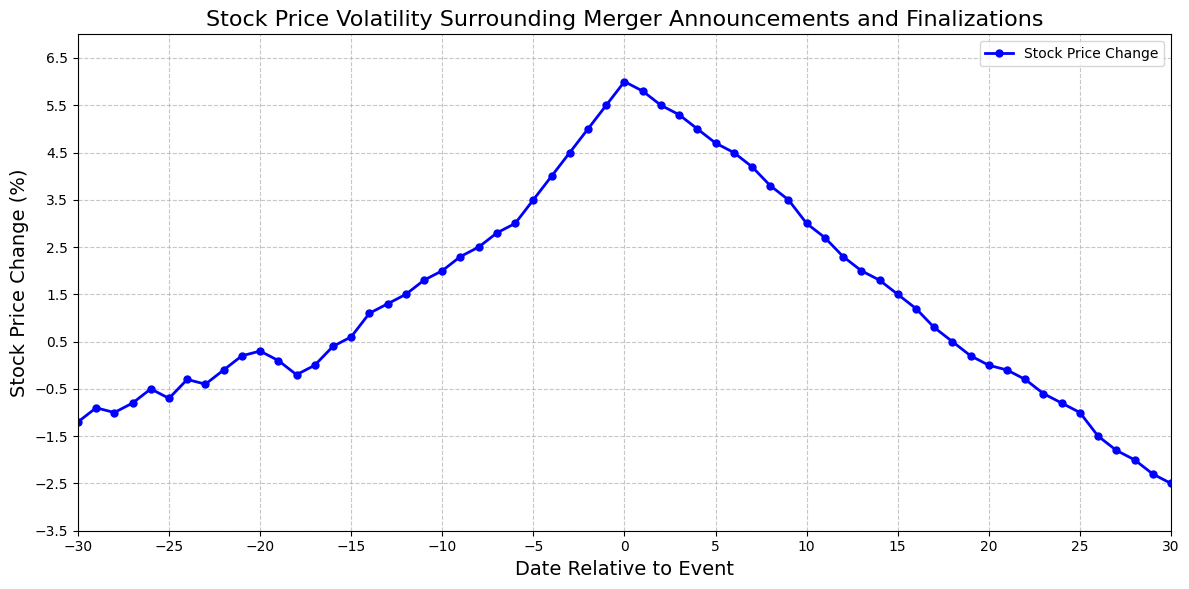What is the stock price change on the day of the merger announcement? To find the stock price change on the day of the merger announcement, look for the data point where the Date is 0. According to the data, on Date 0, the Stock Price Change is 6.0%.
Answer: 6.0% What is the highest stock price change before the merger announcement? To find the highest stock price change before the merger announcement, look at the data points where the Date is less than 0. The highest value among these is 5.5% on Date -1.
Answer: 5.5% What is the trend of the stock price change after the merger finalization? Analyze the data after Date 0. The stock price gradually declines from 6.0% on Date 0 to -2.5% on Date 30.
Answer: Gradually declines What is the total change in stock price from 10 days before to 10 days after the merger? To find the total change, sum the stock price changes from Date -10 to 10. Sum these values: (2.0 + 2.3 + 2.5 + 2.8 + 3.0 + 3.5 + 4.0 + 4.5 + 5.0 + 5.5 + 6.0 + 5.8 + 5.5 + 5.3 + 5.0 + 4.7 + 4.5 + 4.2 + 3.8 + 3.5 + 3.0). This results in a total change of 80.7%.
Answer: 80.7% Which date shows the maximum decline in stock price change after the merger? To find the maximum decline post-merger, note the points after Date 0. The data shows the maximum decline is -2.5% on Date 30.
Answer: 30 How does the stock price change from 5 days before to 5 days after the merger announcement? Compare the stock price changes from Date -5 to 5. The change on Date -5 is 3.5%, and from Date 5, it is 4.7%. The trend shows an increase toward the announcement (from 3.5% to 6.0%) and a slight decline after (from 6.0% to 4.7%).
Answer: Increase before, slight decline after What is the average stock price change 10 days before the merger announcement? To find the average, sum the stock price changes from Date -10 to -1 and divide by 10. The sum is (2.0 + 1.8 + 1.5 + 1.3 + 1.1 + 0.6 + 0.4 + 0.0 + -0.2 + 0.1) = 8.6%. So, the average is 8.6/10 = 0.86%.
Answer: 0.86% Which date marks the transition from negative to positive stock price change? Identify the transition date from negative to positive stock price change by finding the first positive value after negative values. The transition occurs between Date -22 (-0.1%) and Date -21 (0.2%).
Answer: -21 What is the rate of increase in stock price change five days before the merger announcement? Calculate the rate of increase from Date -5 to the announcement (Date 0). From 3.5% to 6.0% (change of 6.0-3.5 = 2.5%) over 5 days yields a daily rate of 2.5/5 = 0.5%. So, the rate of increase is 0.5% per day.
Answer: 0.5% per day How does the volatility pattern appear in the days leading to and following the merger? The pattern shows volatility with initial negative percentages, turning positive and increasing sharply as the merger announcement approaches, peaking on the day of the merger, followed by a gradual decline post-merger finalization back into negative territory.
Answer: Sharp increase, followed by gradual decline 